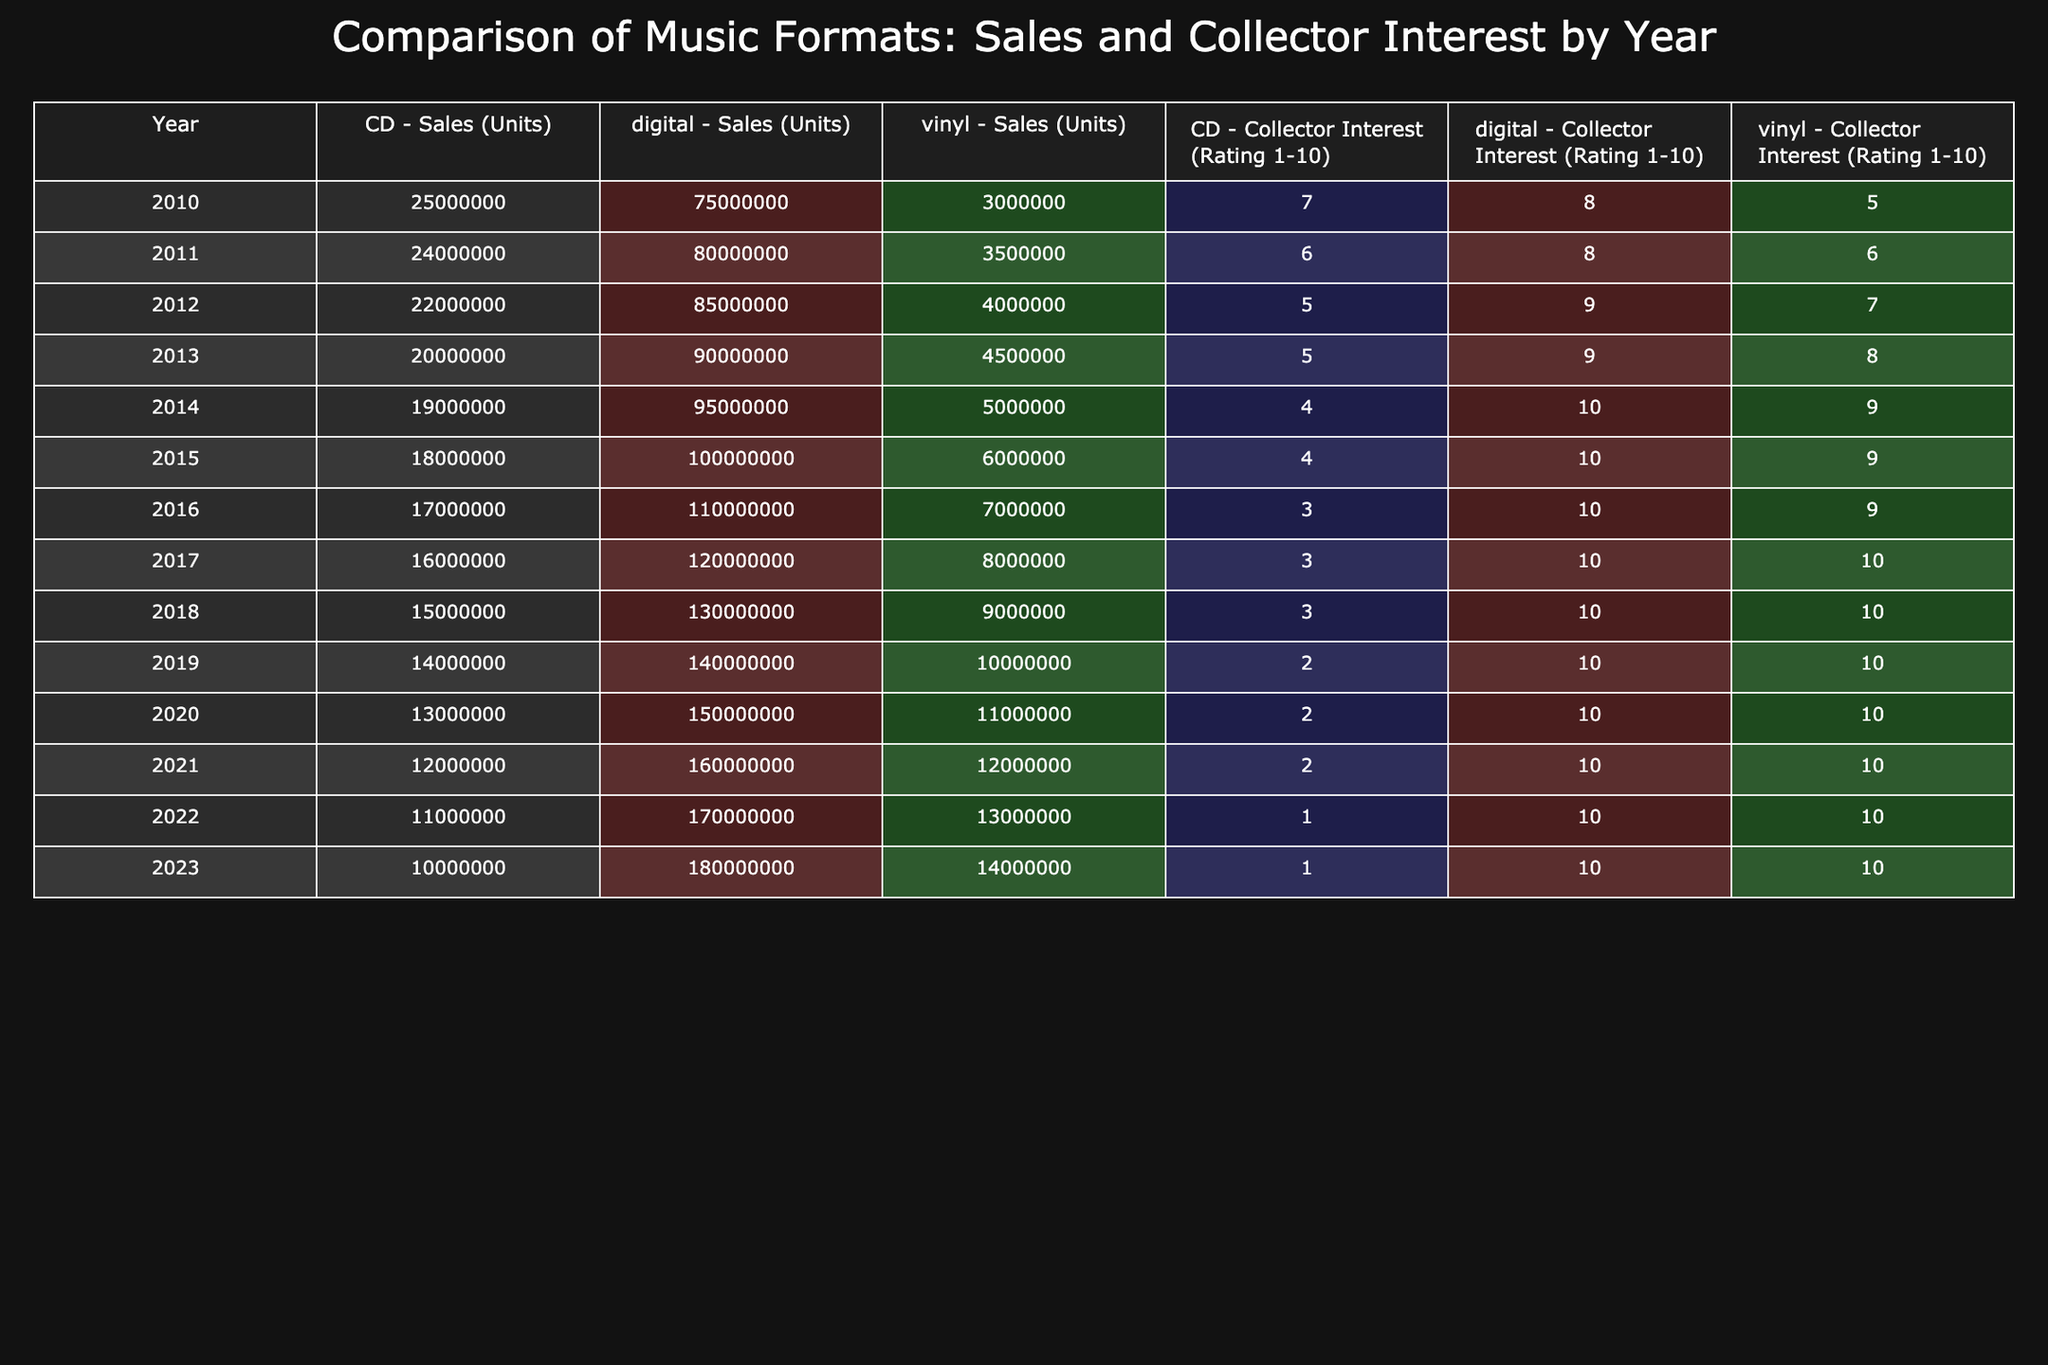What were the sales (units) of vinyl in 2015? The sales of vinyl in 2015 can be found in the row corresponding to that year in the table. The value for 2015 under the vinyl format is 6,000,000 units.
Answer: 6,000,000 In which year did digital sales first exceed 100 million units? By looking at the digital sales column, we can see that the first instance where digital sales exceed 100 million units is in 2015, with sales of exactly 100,000,000 units.
Answer: 2015 What is the average collector interest rating for CDs from 2010 to 2022? To compute the average, we sum the collector interest ratings for CDs across the specified years: (7 + 6 + 5 + 5 + 4 + 4 + 3 + 3 + 3 + 2 + 2 + 1 + 1) = 46. There are 13 data points, so the average is 46 divided by 13, which equals approximately 3.54.
Answer: 3.54 Are vinyl sales consistently higher than CD sales from 2010 to 2023? To determine this, we compare the sales figures for vinyl and CDs across the years. In the majority of years (2010 to 2013), CD sales were higher, but from 2014 onward, vinyl sales surpassed CD sales. Therefore, the statement is false.
Answer: No In which year did collector interest for vinyl reach its highest rating, and what was the rating? Looking at the collector interest ratings for vinyl, we can see that the highest rating of 10 was achieved in 2017 and 2018. Thus, both years have the same maximum rating.
Answer: 2017, 2018 (10) What was the difference in sales (units) between digital and vinyl formats in 2023? In 2023, digital sales were 180,000,000 units and vinyl sales were 14,000,000 units. The difference is calculated as 180,000,000 - 14,000,000 = 166,000,000.
Answer: 166,000,000 What year had the lowest collector interest for CDs, and what was the rating? By examining the collector interest ratings for CDs, we can see the lowest rating occurred in 2022 with a rating of 1.
Answer: 2022 (1) How did the sales of vinyl change from 2010 to 2023? From 2010 to 2023, vinyl sales increased from 3,000,000 units to 14,000,000 units. This indicates a growth trend over the years, specifically a rise of 11,000,000 units over the observed period.
Answer: Increased by 11,000,000 units 